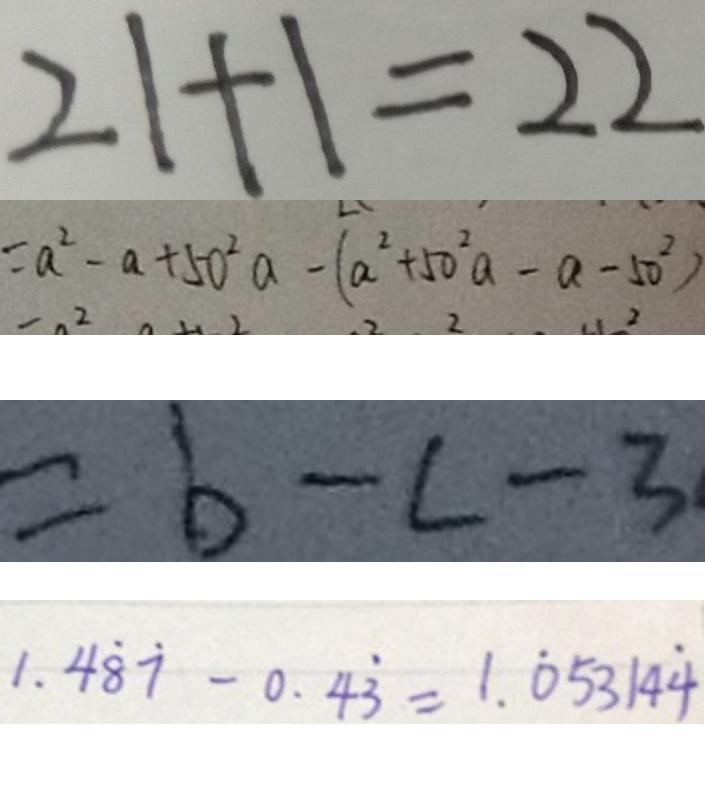Convert formula to latex. <formula><loc_0><loc_0><loc_500><loc_500>2 1 + 1 = 2 2 
 = a ^ { 2 } - a + 5 0 ^ { 2 } a - ( a ^ { 2 } + 5 0 ^ { 2 } a - a - 5 0 ^ { 2 } ) 
 = b - c - 3 
 1 . 4 \dot { 8 } \dot { 7 } - 0 . 4 \dot { 3 } = 1 . \dot { 0 } 5 3 1 4 \dot { 4 }</formula> 